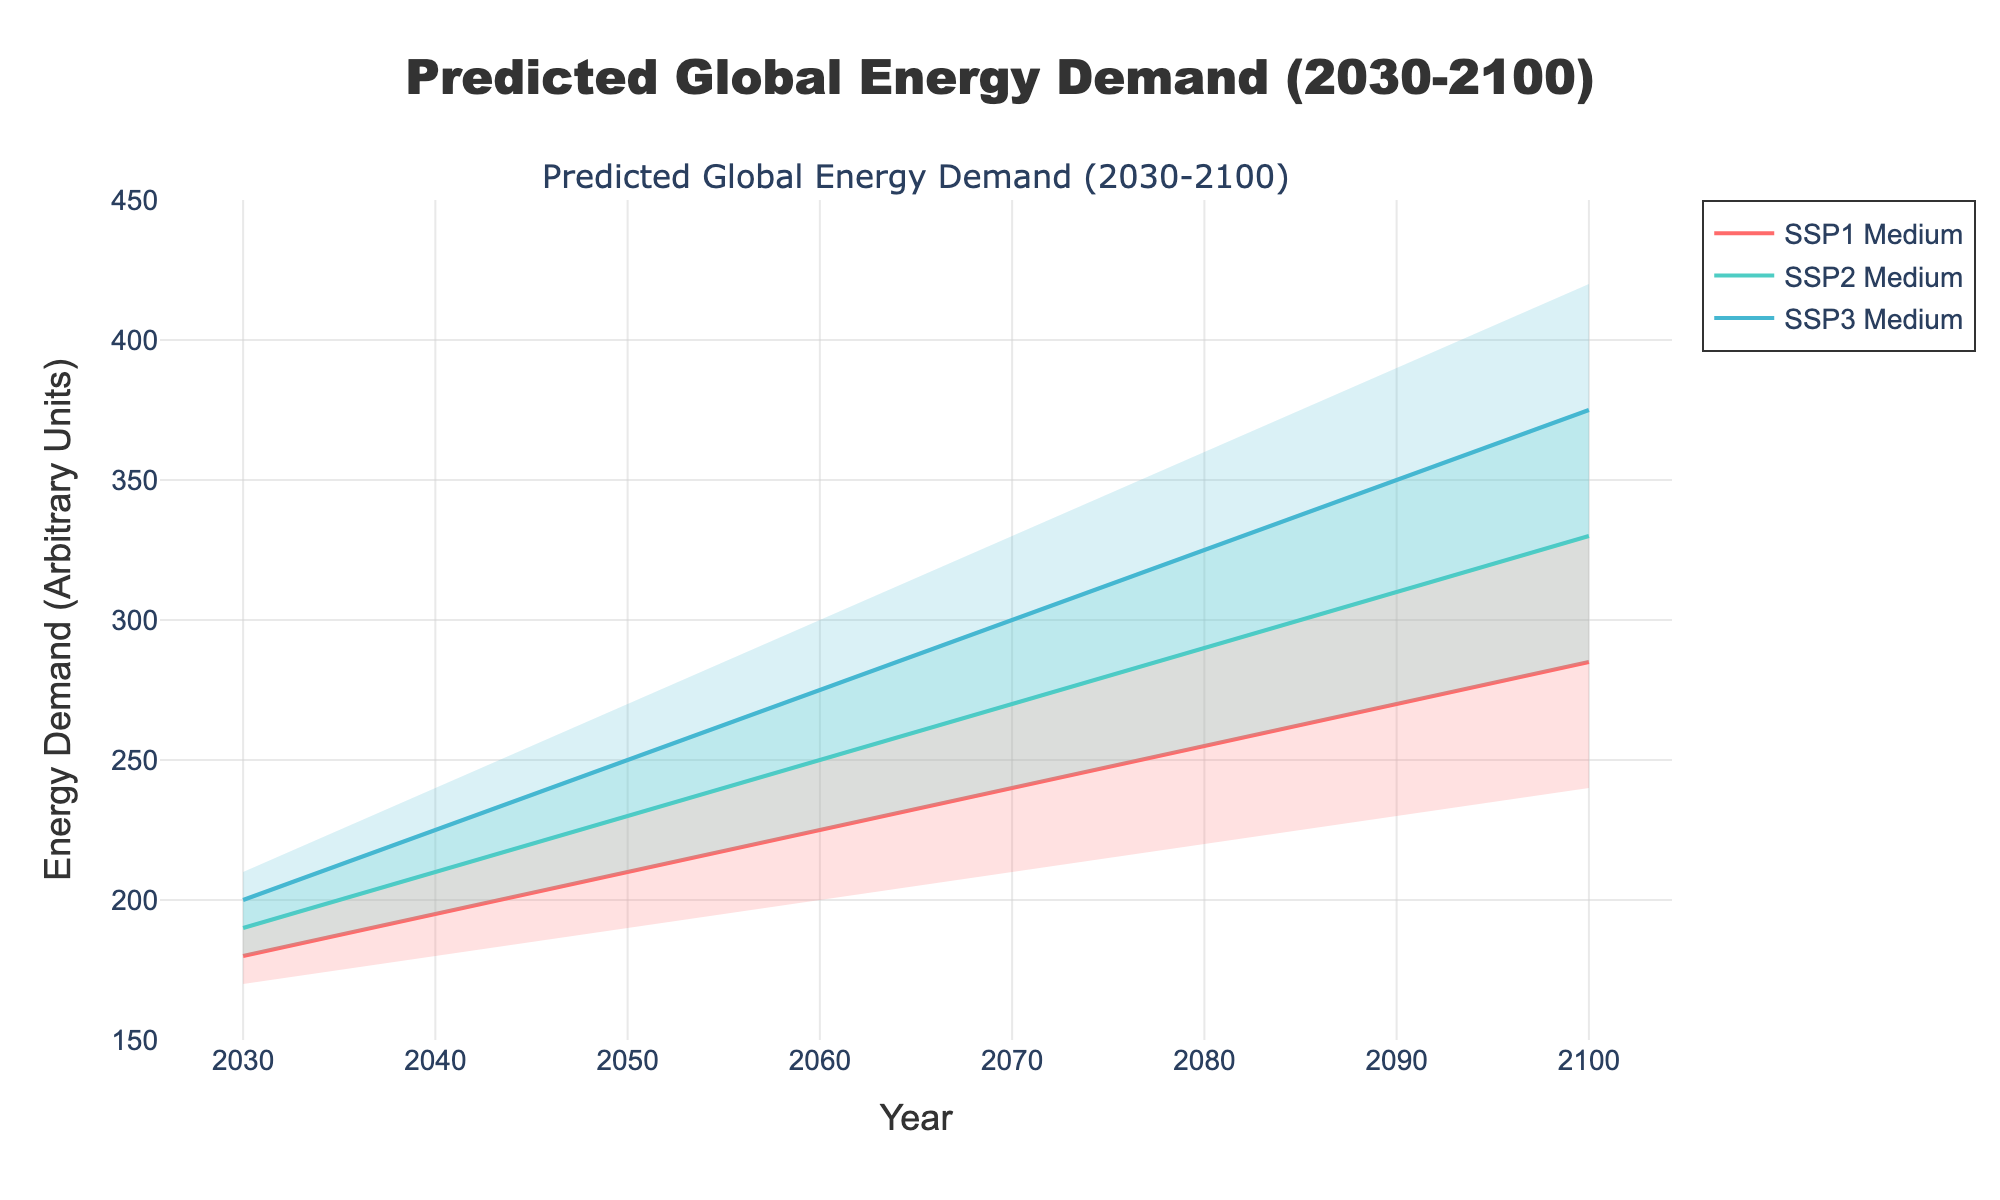What's the title of the figure? The title of the figure is displayed at the top and reads, "Predicted Global Energy Demand (2030-2100)".
Answer: Predicted Global Energy Demand (2030-2100) What are the scenarios represented in the figure? The legend and the labels of the medium lines indicate that three scenarios are represented: SSP1, SSP2, and SSP3.
Answer: SSP1, SSP2, SSP3 Which scenario has the highest predicted energy demand range in 2100? By examining the endpoints of the range for each scenario in 2100, SSP3 has the highest range, with the high end at 420.
Answer: SSP3 What is the energy demand range for SSP1 in 2050? The upper and lower bounds of SSP1 in 2050 can be identified by looking at the filled areas' upper and lower edges at that year. The values are 230 (High) and 190 (Low).
Answer: 190 to 230 Between 2070 and 2080, which SSP scenario shows the largest increase in medium predicted energy demand? To find this, calculate the difference in medium predicted energy demand for each scenario between the years 2070 and 2080:
- SSP1: 255 - 240 = 15
- SSP2: 290 - 270 = 20
- SSP3: 325 - 300 = 25
Hence, SSP3 shows the largest increase.
Answer: SSP3 In which year does the medium energy demand for SSP2 first reach 300? Trace the medium line of SSP2 to see in which year it attains 300. It first reaches 300 in the year 2070.
Answer: 2070 Compare the predicted medium energy demand for SSP1 and SSP2 in 2040. Which one is higher and by how much? The medium predictions in 2040 are 195 for SSP1 and 210 for SSP2. The difference is 210 - 195 = 15, so SSP2 is higher by 15 units.
Answer: SSP2 by 15 units Looking at the filled areas, which range is always overlapping from 2030 to 2100? The ranges that overlap across the entire timeline, from visual inspection, are those of SSP2 (Medium Line) and SSP3 (Low).
Answer: SSP2 and SSP3 How does the change in energy demand from 2030 to 2100 for SSP1 compare to SSP3 for the lower estimates? Calculate the difference between the years 2030 and 2100 for SSP1 and SSP3:
- SSP1 low: 240 - 170 = 70
- SSP3 low: 330 - 190 = 140
SSP3's lower estimate shows a higher change.
Answer: SSP3's lower is higher by 70 units 